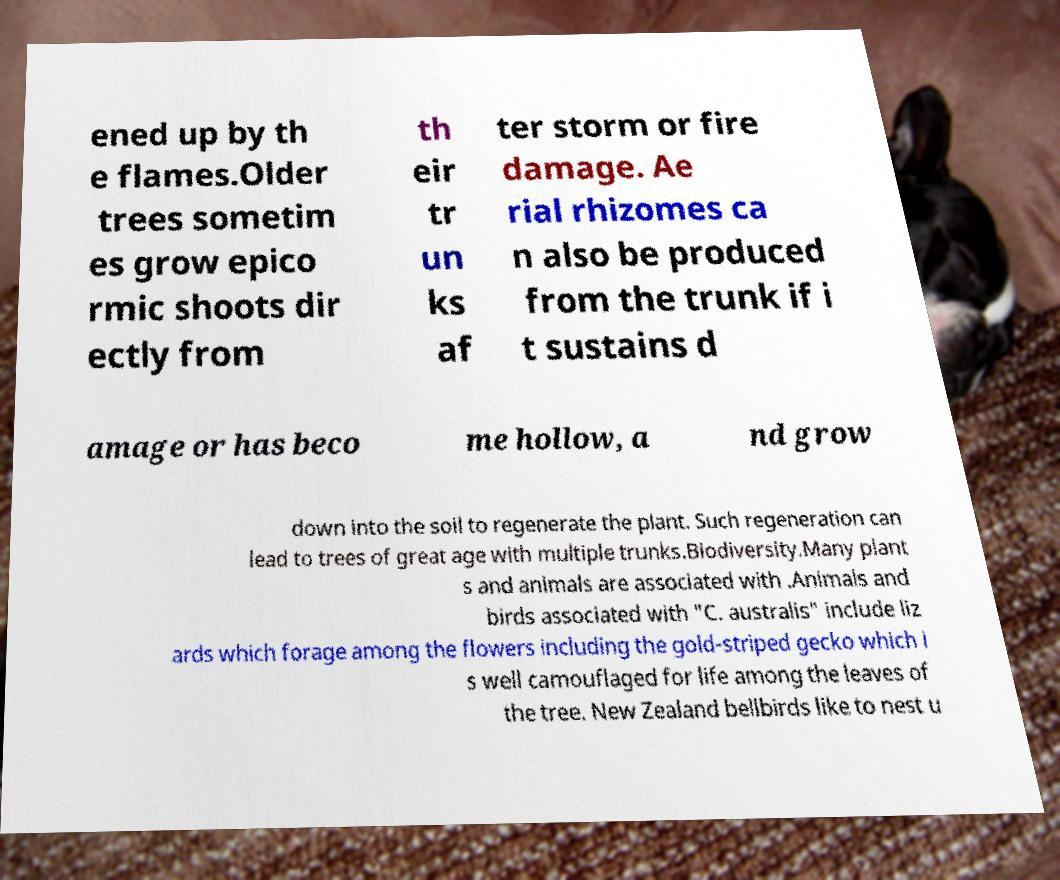For documentation purposes, I need the text within this image transcribed. Could you provide that? ened up by th e flames.Older trees sometim es grow epico rmic shoots dir ectly from th eir tr un ks af ter storm or fire damage. Ae rial rhizomes ca n also be produced from the trunk if i t sustains d amage or has beco me hollow, a nd grow down into the soil to regenerate the plant. Such regeneration can lead to trees of great age with multiple trunks.Biodiversity.Many plant s and animals are associated with .Animals and birds associated with "C. australis" include liz ards which forage among the flowers including the gold-striped gecko which i s well camouflaged for life among the leaves of the tree. New Zealand bellbirds like to nest u 